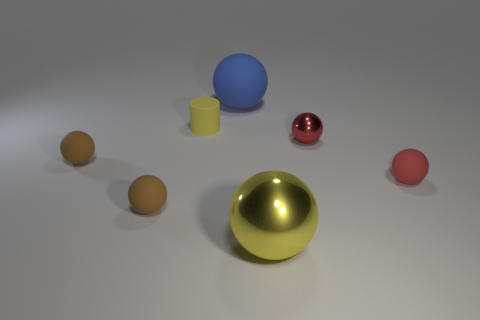Subtract all big blue spheres. How many spheres are left? 5 Subtract all yellow spheres. How many spheres are left? 5 Subtract all blue spheres. Subtract all yellow cylinders. How many spheres are left? 5 Add 1 large shiny objects. How many objects exist? 8 Subtract all cylinders. How many objects are left? 6 Subtract all small rubber things. Subtract all tiny blue shiny objects. How many objects are left? 3 Add 1 large yellow shiny things. How many large yellow shiny things are left? 2 Add 1 tiny yellow matte things. How many tiny yellow matte things exist? 2 Subtract 0 blue cubes. How many objects are left? 7 